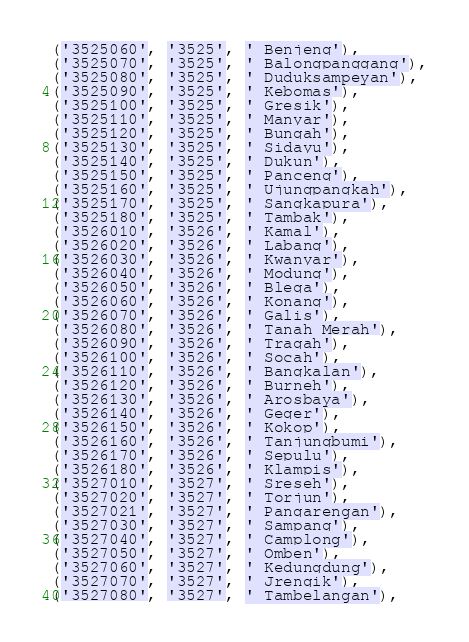Convert code to text. <code><loc_0><loc_0><loc_500><loc_500><_SQL_>('3525060', '3525', ' Benjeng'),
('3525070', '3525', ' Balongpanggang'),
('3525080', '3525', ' Duduksampeyan'),
('3525090', '3525', ' Kebomas'),
('3525100', '3525', ' Gresik'),
('3525110', '3525', ' Manyar'),
('3525120', '3525', ' Bungah'),
('3525130', '3525', ' Sidayu'),
('3525140', '3525', ' Dukun'),
('3525150', '3525', ' Panceng'),
('3525160', '3525', ' Ujungpangkah'),
('3525170', '3525', ' Sangkapura'),
('3525180', '3525', ' Tambak'),
('3526010', '3526', ' Kamal'),
('3526020', '3526', ' Labang'),
('3526030', '3526', ' Kwanyar'),
('3526040', '3526', ' Modung'),
('3526050', '3526', ' Blega'),
('3526060', '3526', ' Konang'),
('3526070', '3526', ' Galis'),
('3526080', '3526', ' Tanah Merah'),
('3526090', '3526', ' Tragah'),
('3526100', '3526', ' Socah'),
('3526110', '3526', ' Bangkalan'),
('3526120', '3526', ' Burneh'),
('3526130', '3526', ' Arosbaya'),
('3526140', '3526', ' Geger'),
('3526150', '3526', ' Kokop'),
('3526160', '3526', ' Tanjungbumi'),
('3526170', '3526', ' Sepulu'),
('3526180', '3526', ' Klampis'),
('3527010', '3527', ' Sreseh'),
('3527020', '3527', ' Torjun'),
('3527021', '3527', ' Pangarengan'),
('3527030', '3527', ' Sampang'),
('3527040', '3527', ' Camplong'),
('3527050', '3527', ' Omben'),
('3527060', '3527', ' Kedungdung'),
('3527070', '3527', ' Jrengik'),
('3527080', '3527', ' Tambelangan'),</code> 